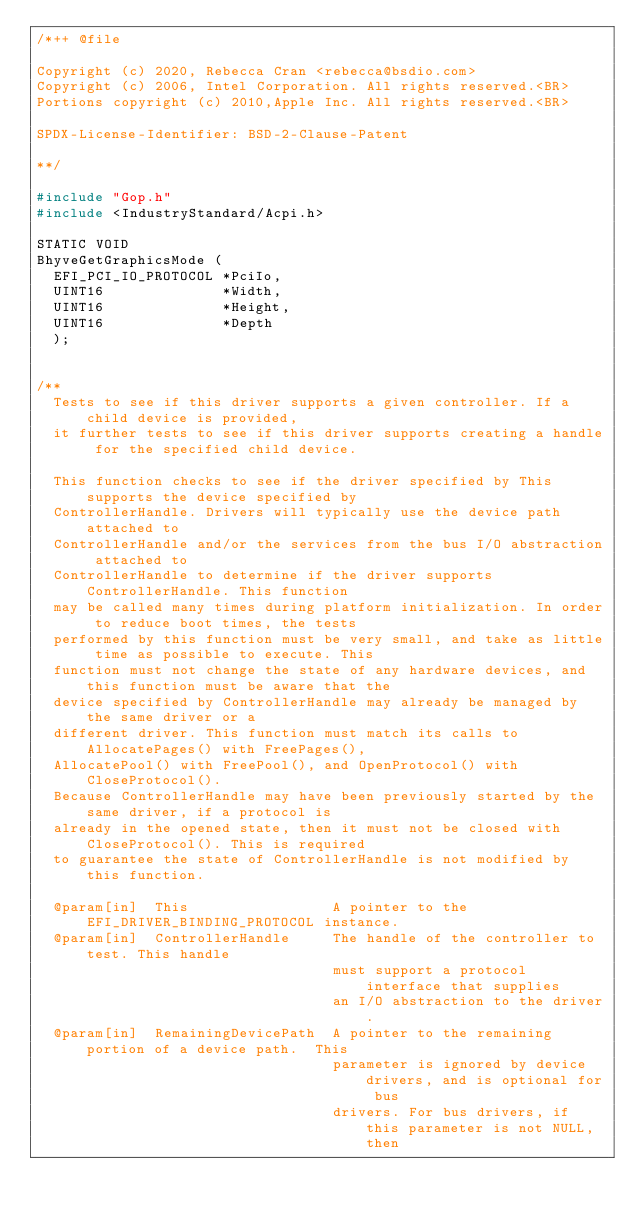Convert code to text. <code><loc_0><loc_0><loc_500><loc_500><_C_>/*++ @file

Copyright (c) 2020, Rebecca Cran <rebecca@bsdio.com>
Copyright (c) 2006, Intel Corporation. All rights reserved.<BR>
Portions copyright (c) 2010,Apple Inc. All rights reserved.<BR>

SPDX-License-Identifier: BSD-2-Clause-Patent

**/

#include "Gop.h"
#include <IndustryStandard/Acpi.h>

STATIC VOID
BhyveGetGraphicsMode (
  EFI_PCI_IO_PROTOCOL *PciIo,
  UINT16              *Width,
  UINT16              *Height,
  UINT16              *Depth
  );


/**
  Tests to see if this driver supports a given controller. If a child device is provided,
  it further tests to see if this driver supports creating a handle for the specified child device.

  This function checks to see if the driver specified by This supports the device specified by
  ControllerHandle. Drivers will typically use the device path attached to
  ControllerHandle and/or the services from the bus I/O abstraction attached to
  ControllerHandle to determine if the driver supports ControllerHandle. This function
  may be called many times during platform initialization. In order to reduce boot times, the tests
  performed by this function must be very small, and take as little time as possible to execute. This
  function must not change the state of any hardware devices, and this function must be aware that the
  device specified by ControllerHandle may already be managed by the same driver or a
  different driver. This function must match its calls to AllocatePages() with FreePages(),
  AllocatePool() with FreePool(), and OpenProtocol() with CloseProtocol().
  Because ControllerHandle may have been previously started by the same driver, if a protocol is
  already in the opened state, then it must not be closed with CloseProtocol(). This is required
  to guarantee the state of ControllerHandle is not modified by this function.

  @param[in]  This                 A pointer to the EFI_DRIVER_BINDING_PROTOCOL instance.
  @param[in]  ControllerHandle     The handle of the controller to test. This handle
                                   must support a protocol interface that supplies
                                   an I/O abstraction to the driver.
  @param[in]  RemainingDevicePath  A pointer to the remaining portion of a device path.  This
                                   parameter is ignored by device drivers, and is optional for bus
                                   drivers. For bus drivers, if this parameter is not NULL, then</code> 